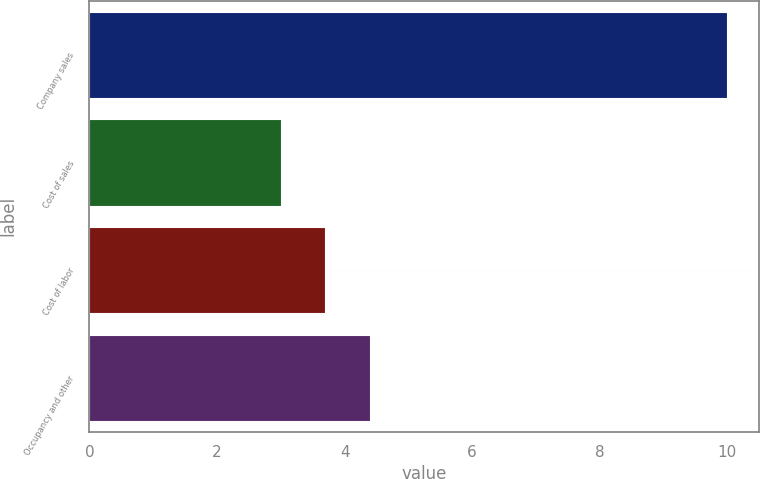<chart> <loc_0><loc_0><loc_500><loc_500><bar_chart><fcel>Company sales<fcel>Cost of sales<fcel>Cost of labor<fcel>Occupancy and other<nl><fcel>10<fcel>3<fcel>3.7<fcel>4.4<nl></chart> 